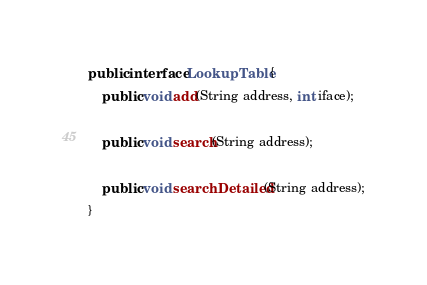<code> <loc_0><loc_0><loc_500><loc_500><_Java_>
public interface LookupTable {
    public void add(String address, int iface);
    
    public void search(String address);
    
    public void searchDetailed(String address);
}
</code> 